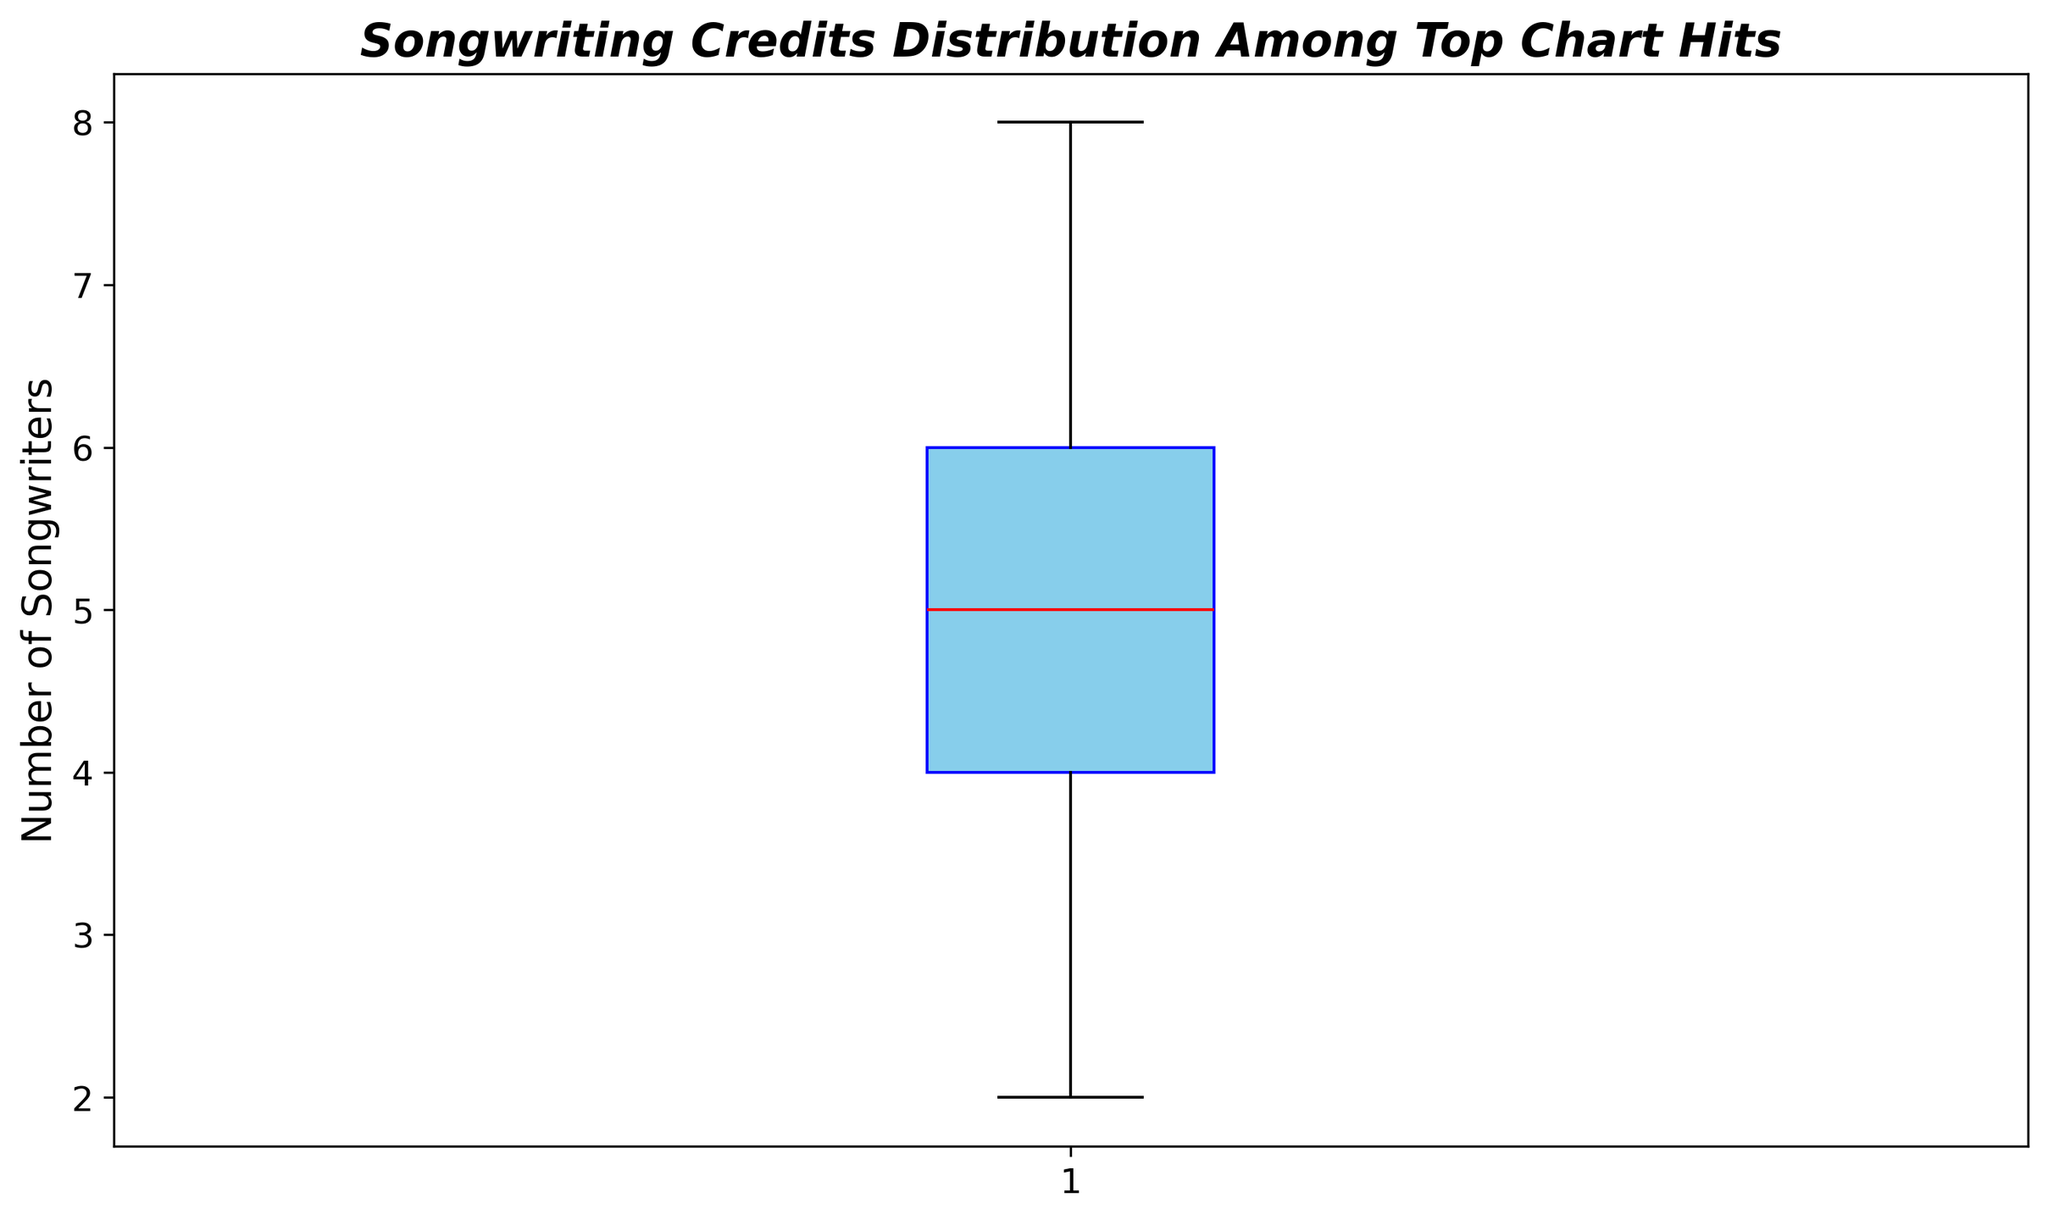What's the median number of songwriters? The median is the middle value when the data is ordered. The box plot visually shows the median with a red line inside the box.
Answer: 5 What's the range of the number of songwriters? The range is the difference between the maximum and minimum values. The maximum is 8 and the minimum is 2. So, the range is 8 - 2.
Answer: 6 Which data point, as represented by the whiskers, indicates the largest deviation from the median? The whiskers show the spread of the data. The largest deviation from the median is on the upper whisker, which reaches up to 8 songwriters.
Answer: 8 Are there any outliers in the distribution? Outliers are typically represented as dots outside the whiskers. According to the plot, there are no outliers indicated.
Answer: No Is the distribution of songwriting credits symmetrical? The symmetry can be determined by the position of the median within the box and the lengths of the whiskers. The median is slightly lower within the box, making the distribution slightly skewed right.
Answer: Slightly skewed right 